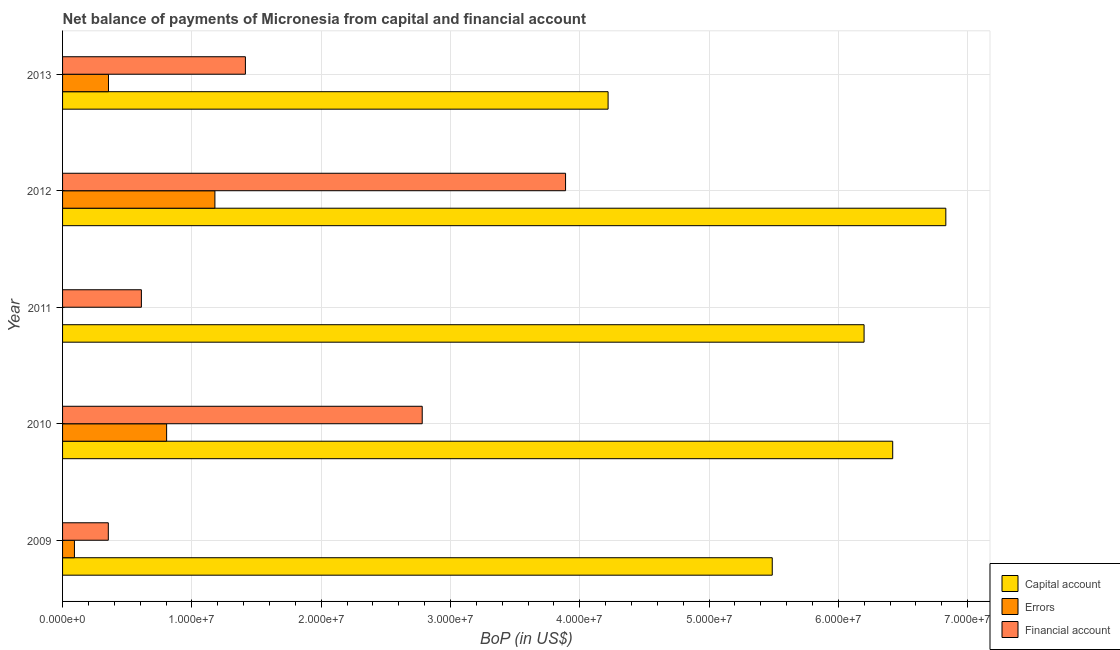How many different coloured bars are there?
Give a very brief answer. 3. How many groups of bars are there?
Make the answer very short. 5. Are the number of bars on each tick of the Y-axis equal?
Provide a succinct answer. No. How many bars are there on the 5th tick from the top?
Offer a terse response. 3. What is the amount of net capital account in 2012?
Your response must be concise. 6.83e+07. Across all years, what is the maximum amount of net capital account?
Offer a terse response. 6.83e+07. Across all years, what is the minimum amount of net capital account?
Offer a terse response. 4.22e+07. In which year was the amount of errors maximum?
Keep it short and to the point. 2012. What is the total amount of errors in the graph?
Offer a very short reply. 2.43e+07. What is the difference between the amount of net capital account in 2009 and that in 2013?
Your answer should be compact. 1.27e+07. What is the difference between the amount of financial account in 2011 and the amount of net capital account in 2009?
Ensure brevity in your answer.  -4.88e+07. What is the average amount of errors per year?
Make the answer very short. 4.86e+06. In the year 2012, what is the difference between the amount of net capital account and amount of financial account?
Make the answer very short. 2.94e+07. Is the amount of net capital account in 2009 less than that in 2013?
Your answer should be compact. No. Is the difference between the amount of errors in 2009 and 2010 greater than the difference between the amount of financial account in 2009 and 2010?
Your answer should be very brief. Yes. What is the difference between the highest and the second highest amount of financial account?
Your answer should be compact. 1.11e+07. What is the difference between the highest and the lowest amount of net capital account?
Offer a terse response. 2.61e+07. In how many years, is the amount of net capital account greater than the average amount of net capital account taken over all years?
Give a very brief answer. 3. Are all the bars in the graph horizontal?
Provide a succinct answer. Yes. How many years are there in the graph?
Provide a succinct answer. 5. Are the values on the major ticks of X-axis written in scientific E-notation?
Offer a very short reply. Yes. Does the graph contain grids?
Make the answer very short. Yes. How many legend labels are there?
Your answer should be very brief. 3. What is the title of the graph?
Provide a succinct answer. Net balance of payments of Micronesia from capital and financial account. What is the label or title of the X-axis?
Ensure brevity in your answer.  BoP (in US$). What is the BoP (in US$) of Capital account in 2009?
Make the answer very short. 5.49e+07. What is the BoP (in US$) in Errors in 2009?
Offer a very short reply. 9.18e+05. What is the BoP (in US$) of Financial account in 2009?
Give a very brief answer. 3.54e+06. What is the BoP (in US$) in Capital account in 2010?
Your answer should be very brief. 6.42e+07. What is the BoP (in US$) of Errors in 2010?
Provide a succinct answer. 8.05e+06. What is the BoP (in US$) in Financial account in 2010?
Offer a very short reply. 2.78e+07. What is the BoP (in US$) in Capital account in 2011?
Make the answer very short. 6.20e+07. What is the BoP (in US$) in Financial account in 2011?
Ensure brevity in your answer.  6.10e+06. What is the BoP (in US$) in Capital account in 2012?
Give a very brief answer. 6.83e+07. What is the BoP (in US$) of Errors in 2012?
Provide a succinct answer. 1.18e+07. What is the BoP (in US$) in Financial account in 2012?
Keep it short and to the point. 3.89e+07. What is the BoP (in US$) of Capital account in 2013?
Your answer should be compact. 4.22e+07. What is the BoP (in US$) in Errors in 2013?
Offer a terse response. 3.55e+06. What is the BoP (in US$) in Financial account in 2013?
Provide a succinct answer. 1.41e+07. Across all years, what is the maximum BoP (in US$) in Capital account?
Your answer should be compact. 6.83e+07. Across all years, what is the maximum BoP (in US$) of Errors?
Ensure brevity in your answer.  1.18e+07. Across all years, what is the maximum BoP (in US$) of Financial account?
Provide a succinct answer. 3.89e+07. Across all years, what is the minimum BoP (in US$) in Capital account?
Provide a short and direct response. 4.22e+07. Across all years, what is the minimum BoP (in US$) of Financial account?
Your answer should be compact. 3.54e+06. What is the total BoP (in US$) in Capital account in the graph?
Ensure brevity in your answer.  2.92e+08. What is the total BoP (in US$) in Errors in the graph?
Make the answer very short. 2.43e+07. What is the total BoP (in US$) in Financial account in the graph?
Your response must be concise. 9.05e+07. What is the difference between the BoP (in US$) of Capital account in 2009 and that in 2010?
Provide a succinct answer. -9.31e+06. What is the difference between the BoP (in US$) in Errors in 2009 and that in 2010?
Provide a succinct answer. -7.13e+06. What is the difference between the BoP (in US$) of Financial account in 2009 and that in 2010?
Offer a very short reply. -2.43e+07. What is the difference between the BoP (in US$) in Capital account in 2009 and that in 2011?
Your answer should be very brief. -7.10e+06. What is the difference between the BoP (in US$) of Financial account in 2009 and that in 2011?
Your response must be concise. -2.56e+06. What is the difference between the BoP (in US$) in Capital account in 2009 and that in 2012?
Your response must be concise. -1.34e+07. What is the difference between the BoP (in US$) of Errors in 2009 and that in 2012?
Your response must be concise. -1.09e+07. What is the difference between the BoP (in US$) of Financial account in 2009 and that in 2012?
Make the answer very short. -3.54e+07. What is the difference between the BoP (in US$) of Capital account in 2009 and that in 2013?
Give a very brief answer. 1.27e+07. What is the difference between the BoP (in US$) in Errors in 2009 and that in 2013?
Give a very brief answer. -2.63e+06. What is the difference between the BoP (in US$) in Financial account in 2009 and that in 2013?
Provide a short and direct response. -1.06e+07. What is the difference between the BoP (in US$) of Capital account in 2010 and that in 2011?
Make the answer very short. 2.21e+06. What is the difference between the BoP (in US$) in Financial account in 2010 and that in 2011?
Keep it short and to the point. 2.17e+07. What is the difference between the BoP (in US$) in Capital account in 2010 and that in 2012?
Give a very brief answer. -4.11e+06. What is the difference between the BoP (in US$) in Errors in 2010 and that in 2012?
Provide a succinct answer. -3.73e+06. What is the difference between the BoP (in US$) in Financial account in 2010 and that in 2012?
Your response must be concise. -1.11e+07. What is the difference between the BoP (in US$) of Capital account in 2010 and that in 2013?
Your answer should be very brief. 2.20e+07. What is the difference between the BoP (in US$) in Errors in 2010 and that in 2013?
Keep it short and to the point. 4.50e+06. What is the difference between the BoP (in US$) of Financial account in 2010 and that in 2013?
Offer a terse response. 1.37e+07. What is the difference between the BoP (in US$) in Capital account in 2011 and that in 2012?
Keep it short and to the point. -6.32e+06. What is the difference between the BoP (in US$) of Financial account in 2011 and that in 2012?
Provide a short and direct response. -3.28e+07. What is the difference between the BoP (in US$) in Capital account in 2011 and that in 2013?
Give a very brief answer. 1.98e+07. What is the difference between the BoP (in US$) in Financial account in 2011 and that in 2013?
Ensure brevity in your answer.  -8.04e+06. What is the difference between the BoP (in US$) in Capital account in 2012 and that in 2013?
Make the answer very short. 2.61e+07. What is the difference between the BoP (in US$) in Errors in 2012 and that in 2013?
Ensure brevity in your answer.  8.23e+06. What is the difference between the BoP (in US$) of Financial account in 2012 and that in 2013?
Your response must be concise. 2.48e+07. What is the difference between the BoP (in US$) of Capital account in 2009 and the BoP (in US$) of Errors in 2010?
Offer a terse response. 4.68e+07. What is the difference between the BoP (in US$) of Capital account in 2009 and the BoP (in US$) of Financial account in 2010?
Provide a succinct answer. 2.71e+07. What is the difference between the BoP (in US$) of Errors in 2009 and the BoP (in US$) of Financial account in 2010?
Provide a succinct answer. -2.69e+07. What is the difference between the BoP (in US$) of Capital account in 2009 and the BoP (in US$) of Financial account in 2011?
Make the answer very short. 4.88e+07. What is the difference between the BoP (in US$) in Errors in 2009 and the BoP (in US$) in Financial account in 2011?
Your response must be concise. -5.18e+06. What is the difference between the BoP (in US$) of Capital account in 2009 and the BoP (in US$) of Errors in 2012?
Your answer should be compact. 4.31e+07. What is the difference between the BoP (in US$) of Capital account in 2009 and the BoP (in US$) of Financial account in 2012?
Give a very brief answer. 1.60e+07. What is the difference between the BoP (in US$) in Errors in 2009 and the BoP (in US$) in Financial account in 2012?
Keep it short and to the point. -3.80e+07. What is the difference between the BoP (in US$) of Capital account in 2009 and the BoP (in US$) of Errors in 2013?
Make the answer very short. 5.13e+07. What is the difference between the BoP (in US$) in Capital account in 2009 and the BoP (in US$) in Financial account in 2013?
Offer a very short reply. 4.07e+07. What is the difference between the BoP (in US$) of Errors in 2009 and the BoP (in US$) of Financial account in 2013?
Offer a terse response. -1.32e+07. What is the difference between the BoP (in US$) of Capital account in 2010 and the BoP (in US$) of Financial account in 2011?
Your answer should be very brief. 5.81e+07. What is the difference between the BoP (in US$) in Errors in 2010 and the BoP (in US$) in Financial account in 2011?
Make the answer very short. 1.95e+06. What is the difference between the BoP (in US$) of Capital account in 2010 and the BoP (in US$) of Errors in 2012?
Give a very brief answer. 5.24e+07. What is the difference between the BoP (in US$) in Capital account in 2010 and the BoP (in US$) in Financial account in 2012?
Keep it short and to the point. 2.53e+07. What is the difference between the BoP (in US$) of Errors in 2010 and the BoP (in US$) of Financial account in 2012?
Provide a short and direct response. -3.09e+07. What is the difference between the BoP (in US$) of Capital account in 2010 and the BoP (in US$) of Errors in 2013?
Keep it short and to the point. 6.06e+07. What is the difference between the BoP (in US$) of Capital account in 2010 and the BoP (in US$) of Financial account in 2013?
Give a very brief answer. 5.01e+07. What is the difference between the BoP (in US$) in Errors in 2010 and the BoP (in US$) in Financial account in 2013?
Your response must be concise. -6.09e+06. What is the difference between the BoP (in US$) in Capital account in 2011 and the BoP (in US$) in Errors in 2012?
Offer a very short reply. 5.02e+07. What is the difference between the BoP (in US$) of Capital account in 2011 and the BoP (in US$) of Financial account in 2012?
Your response must be concise. 2.31e+07. What is the difference between the BoP (in US$) of Capital account in 2011 and the BoP (in US$) of Errors in 2013?
Provide a short and direct response. 5.84e+07. What is the difference between the BoP (in US$) of Capital account in 2011 and the BoP (in US$) of Financial account in 2013?
Your answer should be compact. 4.78e+07. What is the difference between the BoP (in US$) of Capital account in 2012 and the BoP (in US$) of Errors in 2013?
Provide a short and direct response. 6.48e+07. What is the difference between the BoP (in US$) of Capital account in 2012 and the BoP (in US$) of Financial account in 2013?
Your answer should be very brief. 5.42e+07. What is the difference between the BoP (in US$) in Errors in 2012 and the BoP (in US$) in Financial account in 2013?
Offer a very short reply. -2.36e+06. What is the average BoP (in US$) in Capital account per year?
Offer a very short reply. 5.83e+07. What is the average BoP (in US$) in Errors per year?
Provide a short and direct response. 4.86e+06. What is the average BoP (in US$) of Financial account per year?
Offer a very short reply. 1.81e+07. In the year 2009, what is the difference between the BoP (in US$) in Capital account and BoP (in US$) in Errors?
Your answer should be compact. 5.40e+07. In the year 2009, what is the difference between the BoP (in US$) of Capital account and BoP (in US$) of Financial account?
Make the answer very short. 5.13e+07. In the year 2009, what is the difference between the BoP (in US$) in Errors and BoP (in US$) in Financial account?
Offer a terse response. -2.62e+06. In the year 2010, what is the difference between the BoP (in US$) in Capital account and BoP (in US$) in Errors?
Give a very brief answer. 5.62e+07. In the year 2010, what is the difference between the BoP (in US$) in Capital account and BoP (in US$) in Financial account?
Ensure brevity in your answer.  3.64e+07. In the year 2010, what is the difference between the BoP (in US$) of Errors and BoP (in US$) of Financial account?
Your response must be concise. -1.98e+07. In the year 2011, what is the difference between the BoP (in US$) of Capital account and BoP (in US$) of Financial account?
Offer a terse response. 5.59e+07. In the year 2012, what is the difference between the BoP (in US$) of Capital account and BoP (in US$) of Errors?
Your response must be concise. 5.65e+07. In the year 2012, what is the difference between the BoP (in US$) of Capital account and BoP (in US$) of Financial account?
Ensure brevity in your answer.  2.94e+07. In the year 2012, what is the difference between the BoP (in US$) in Errors and BoP (in US$) in Financial account?
Your answer should be very brief. -2.71e+07. In the year 2013, what is the difference between the BoP (in US$) of Capital account and BoP (in US$) of Errors?
Provide a short and direct response. 3.86e+07. In the year 2013, what is the difference between the BoP (in US$) in Capital account and BoP (in US$) in Financial account?
Your answer should be compact. 2.80e+07. In the year 2013, what is the difference between the BoP (in US$) of Errors and BoP (in US$) of Financial account?
Offer a very short reply. -1.06e+07. What is the ratio of the BoP (in US$) of Capital account in 2009 to that in 2010?
Offer a terse response. 0.85. What is the ratio of the BoP (in US$) in Errors in 2009 to that in 2010?
Ensure brevity in your answer.  0.11. What is the ratio of the BoP (in US$) of Financial account in 2009 to that in 2010?
Provide a short and direct response. 0.13. What is the ratio of the BoP (in US$) in Capital account in 2009 to that in 2011?
Your answer should be very brief. 0.89. What is the ratio of the BoP (in US$) of Financial account in 2009 to that in 2011?
Your answer should be compact. 0.58. What is the ratio of the BoP (in US$) in Capital account in 2009 to that in 2012?
Offer a terse response. 0.8. What is the ratio of the BoP (in US$) in Errors in 2009 to that in 2012?
Give a very brief answer. 0.08. What is the ratio of the BoP (in US$) of Financial account in 2009 to that in 2012?
Offer a very short reply. 0.09. What is the ratio of the BoP (in US$) of Capital account in 2009 to that in 2013?
Keep it short and to the point. 1.3. What is the ratio of the BoP (in US$) in Errors in 2009 to that in 2013?
Your answer should be very brief. 0.26. What is the ratio of the BoP (in US$) in Financial account in 2009 to that in 2013?
Your response must be concise. 0.25. What is the ratio of the BoP (in US$) in Capital account in 2010 to that in 2011?
Keep it short and to the point. 1.04. What is the ratio of the BoP (in US$) of Financial account in 2010 to that in 2011?
Your answer should be very brief. 4.56. What is the ratio of the BoP (in US$) of Capital account in 2010 to that in 2012?
Your answer should be very brief. 0.94. What is the ratio of the BoP (in US$) of Errors in 2010 to that in 2012?
Your answer should be very brief. 0.68. What is the ratio of the BoP (in US$) in Financial account in 2010 to that in 2012?
Make the answer very short. 0.71. What is the ratio of the BoP (in US$) of Capital account in 2010 to that in 2013?
Keep it short and to the point. 1.52. What is the ratio of the BoP (in US$) of Errors in 2010 to that in 2013?
Offer a very short reply. 2.27. What is the ratio of the BoP (in US$) in Financial account in 2010 to that in 2013?
Keep it short and to the point. 1.97. What is the ratio of the BoP (in US$) in Capital account in 2011 to that in 2012?
Provide a succinct answer. 0.91. What is the ratio of the BoP (in US$) in Financial account in 2011 to that in 2012?
Your answer should be compact. 0.16. What is the ratio of the BoP (in US$) in Capital account in 2011 to that in 2013?
Provide a succinct answer. 1.47. What is the ratio of the BoP (in US$) in Financial account in 2011 to that in 2013?
Ensure brevity in your answer.  0.43. What is the ratio of the BoP (in US$) of Capital account in 2012 to that in 2013?
Keep it short and to the point. 1.62. What is the ratio of the BoP (in US$) of Errors in 2012 to that in 2013?
Provide a short and direct response. 3.32. What is the ratio of the BoP (in US$) in Financial account in 2012 to that in 2013?
Keep it short and to the point. 2.75. What is the difference between the highest and the second highest BoP (in US$) in Capital account?
Give a very brief answer. 4.11e+06. What is the difference between the highest and the second highest BoP (in US$) of Errors?
Offer a terse response. 3.73e+06. What is the difference between the highest and the second highest BoP (in US$) of Financial account?
Your answer should be very brief. 1.11e+07. What is the difference between the highest and the lowest BoP (in US$) of Capital account?
Keep it short and to the point. 2.61e+07. What is the difference between the highest and the lowest BoP (in US$) of Errors?
Make the answer very short. 1.18e+07. What is the difference between the highest and the lowest BoP (in US$) of Financial account?
Provide a succinct answer. 3.54e+07. 